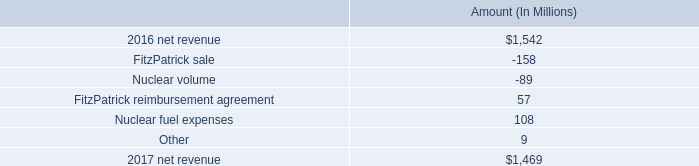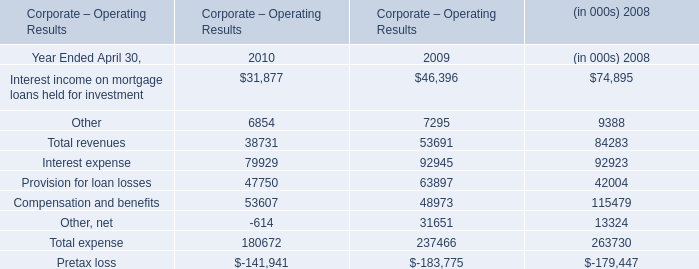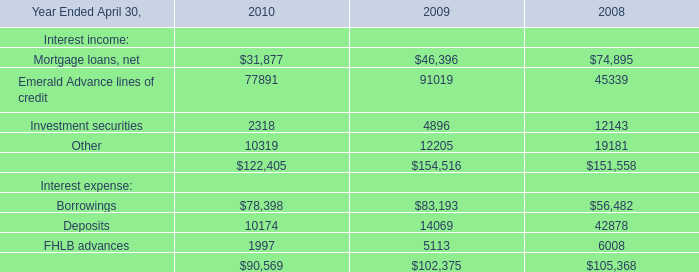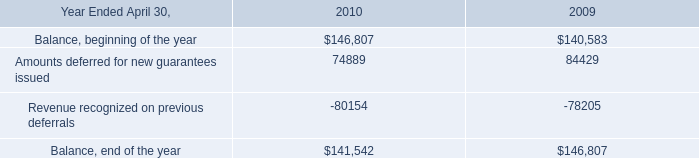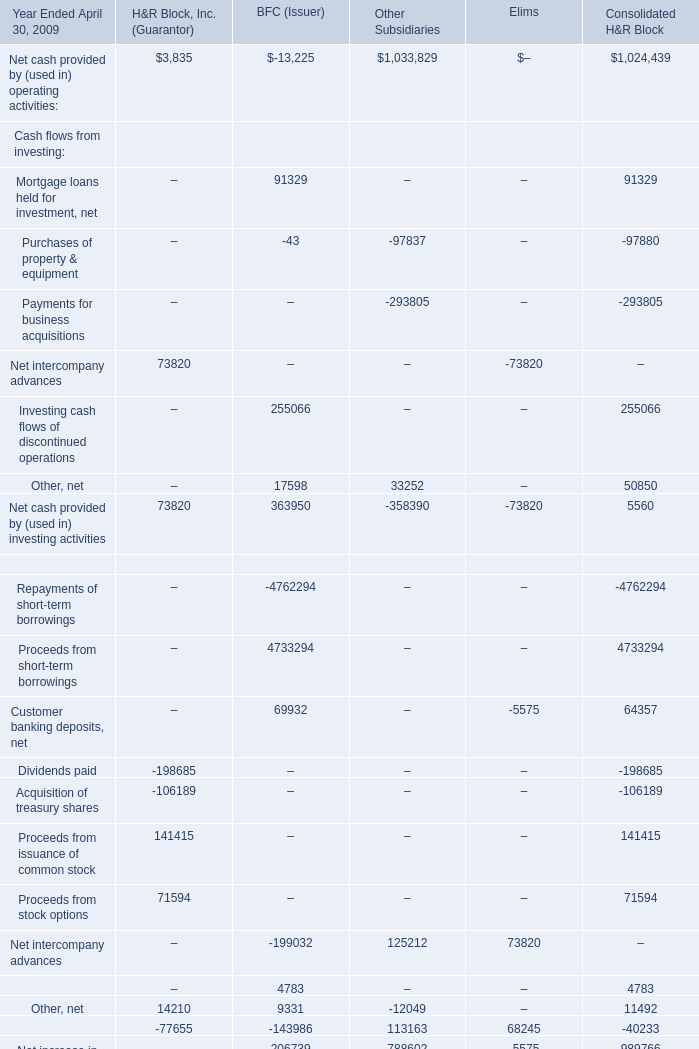What was the total amount of H&R Block, Inc. (Guarantor) excluding those H&R Block, Inc. (Guarantor) greater than 0 in 2009? 
Computations: ((-198685 - 106189) - 77655)
Answer: -382529.0. 